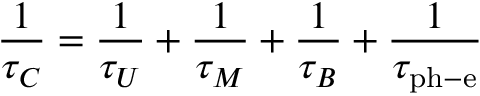<formula> <loc_0><loc_0><loc_500><loc_500>{ \frac { 1 } { \tau _ { C } } } = { \frac { 1 } { \tau _ { U } } } + { \frac { 1 } { \tau _ { M } } } + { \frac { 1 } { \tau _ { B } } } + { \frac { 1 } { \tau _ { p h - e } } }</formula> 